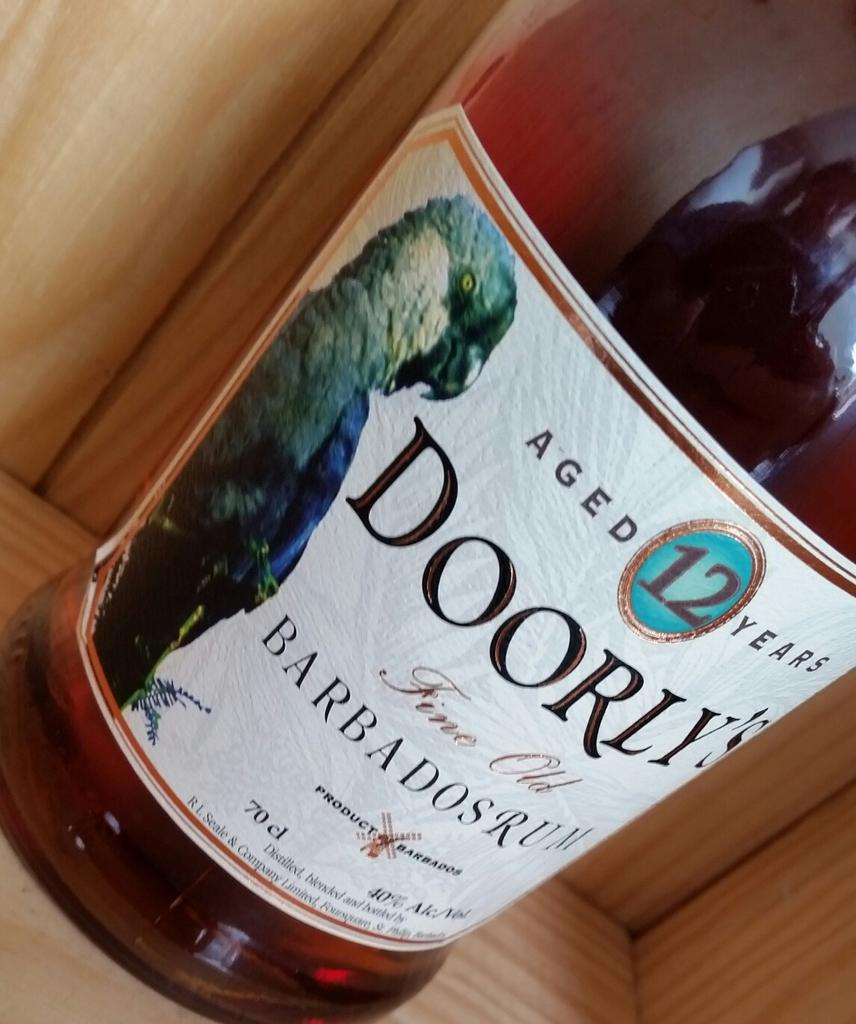What can be seen in the image? There is a bottle in the image. Where is the bottle located? The bottle is on a wooden surface. What is on the bottle? There is a sticker on the bottle. What is written on the sticker? Something is written on the sticker. What image is on the sticker? There is a picture of a bird on the sticker. How does the spy use the bottle in the image? There is no spy present in the image, and the bottle is not being used for any specific purpose related to spying. 